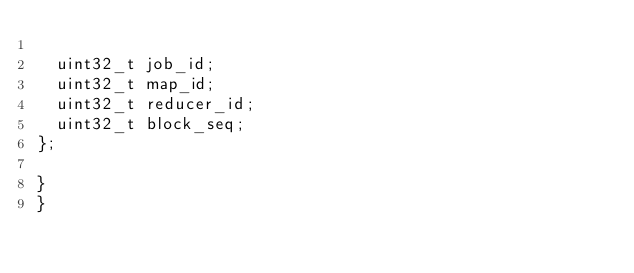Convert code to text. <code><loc_0><loc_0><loc_500><loc_500><_C++_>
  uint32_t job_id;
  uint32_t map_id;
  uint32_t reducer_id;
  uint32_t block_seq;
};

}
}
</code> 